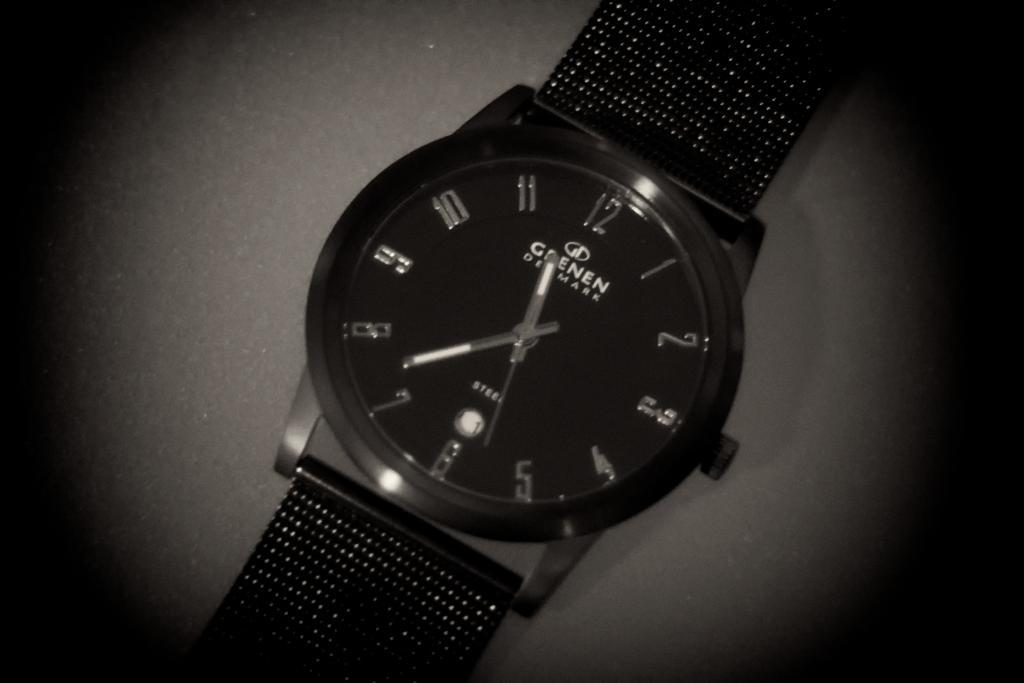Provide a one-sentence caption for the provided image. A Grenen Denmark watch has a time of about 11:37. 